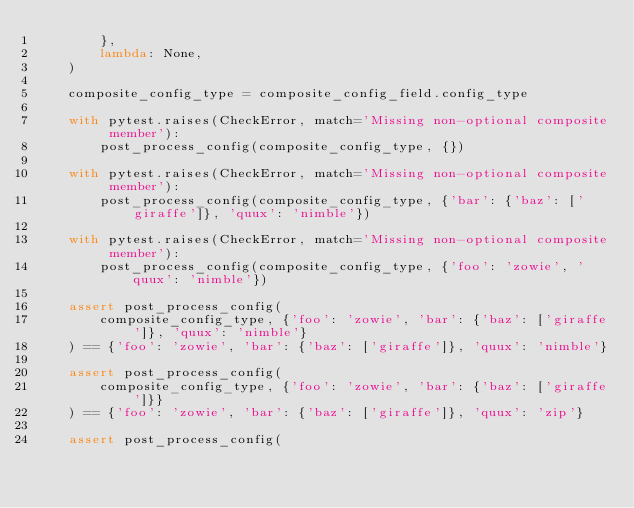<code> <loc_0><loc_0><loc_500><loc_500><_Python_>        },
        lambda: None,
    )

    composite_config_type = composite_config_field.config_type

    with pytest.raises(CheckError, match='Missing non-optional composite member'):
        post_process_config(composite_config_type, {})

    with pytest.raises(CheckError, match='Missing non-optional composite member'):
        post_process_config(composite_config_type, {'bar': {'baz': ['giraffe']}, 'quux': 'nimble'})

    with pytest.raises(CheckError, match='Missing non-optional composite member'):
        post_process_config(composite_config_type, {'foo': 'zowie', 'quux': 'nimble'})

    assert post_process_config(
        composite_config_type, {'foo': 'zowie', 'bar': {'baz': ['giraffe']}, 'quux': 'nimble'}
    ) == {'foo': 'zowie', 'bar': {'baz': ['giraffe']}, 'quux': 'nimble'}

    assert post_process_config(
        composite_config_type, {'foo': 'zowie', 'bar': {'baz': ['giraffe']}}
    ) == {'foo': 'zowie', 'bar': {'baz': ['giraffe']}, 'quux': 'zip'}

    assert post_process_config(</code> 